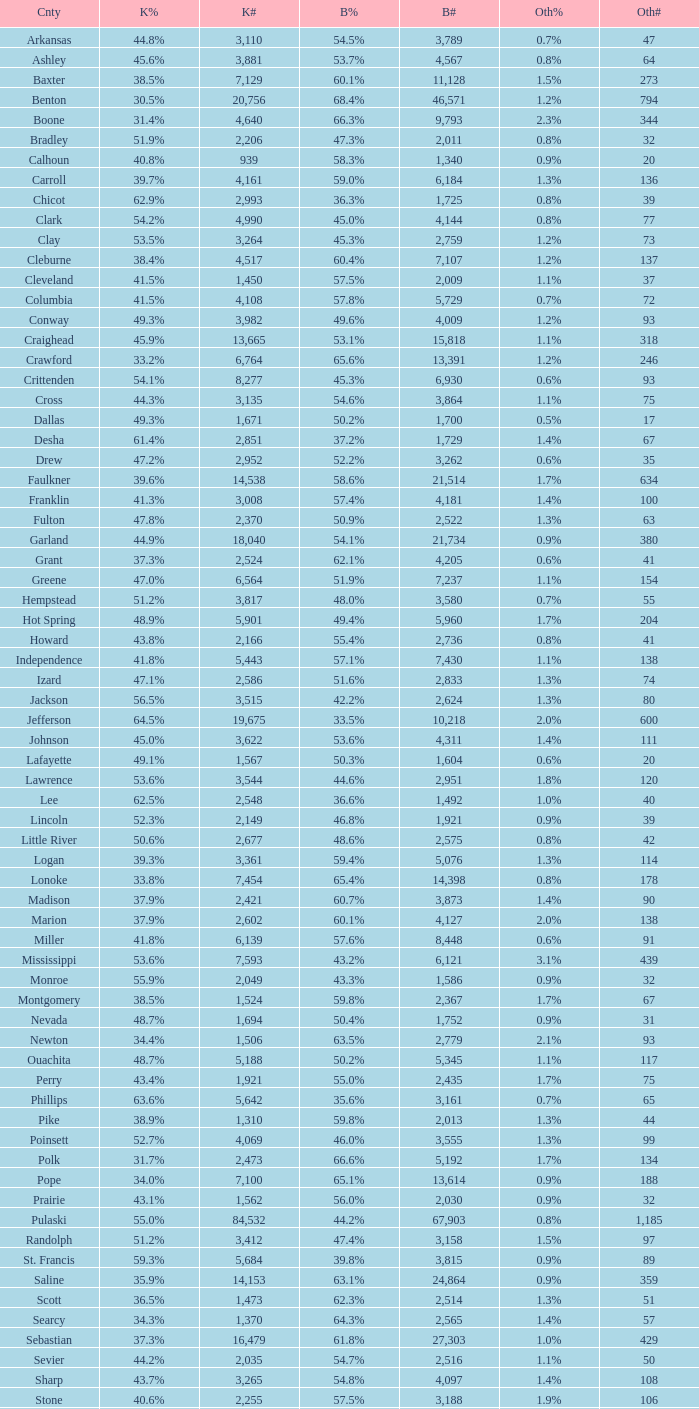What is the lowest Bush#, when Bush% is "65.4%"? 14398.0. 